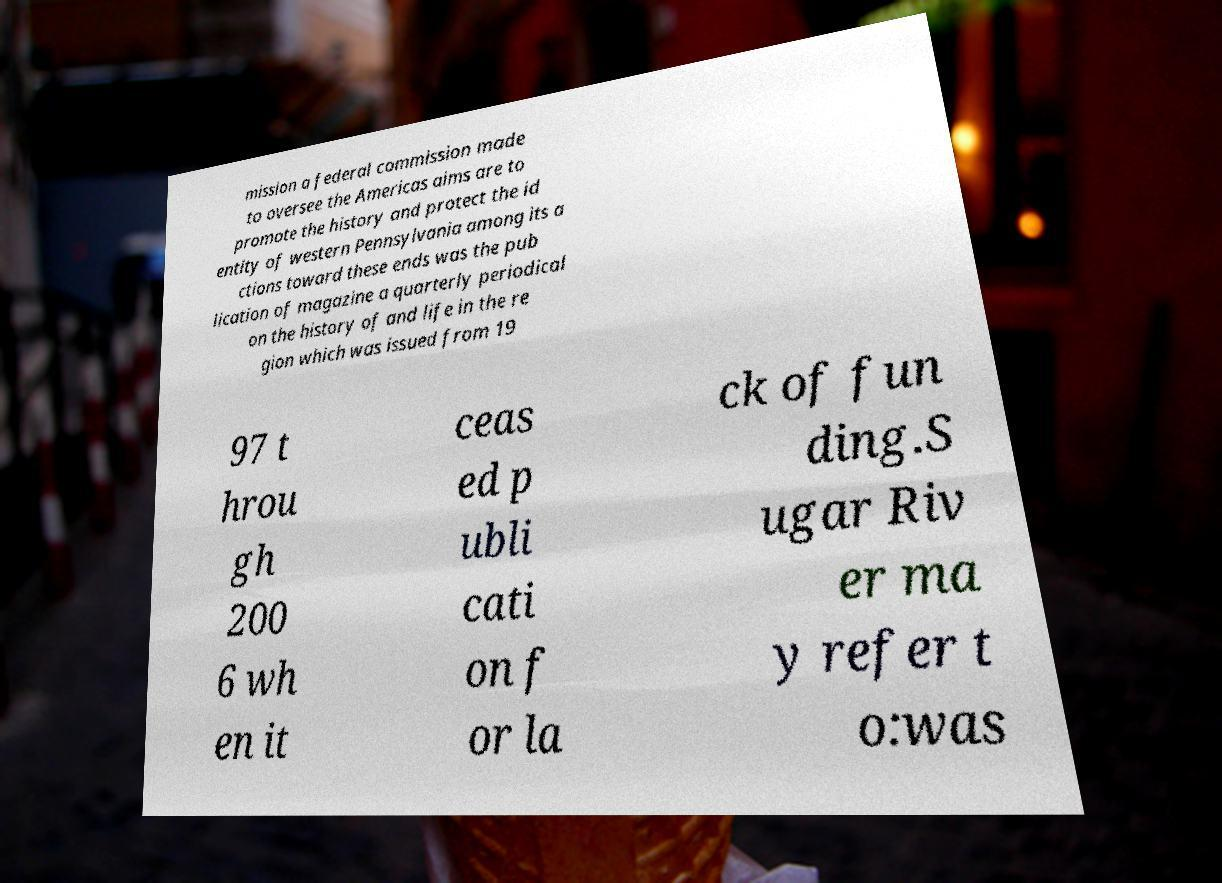Could you assist in decoding the text presented in this image and type it out clearly? mission a federal commission made to oversee the Americas aims are to promote the history and protect the id entity of western Pennsylvania among its a ctions toward these ends was the pub lication of magazine a quarterly periodical on the history of and life in the re gion which was issued from 19 97 t hrou gh 200 6 wh en it ceas ed p ubli cati on f or la ck of fun ding.S ugar Riv er ma y refer t o:was 